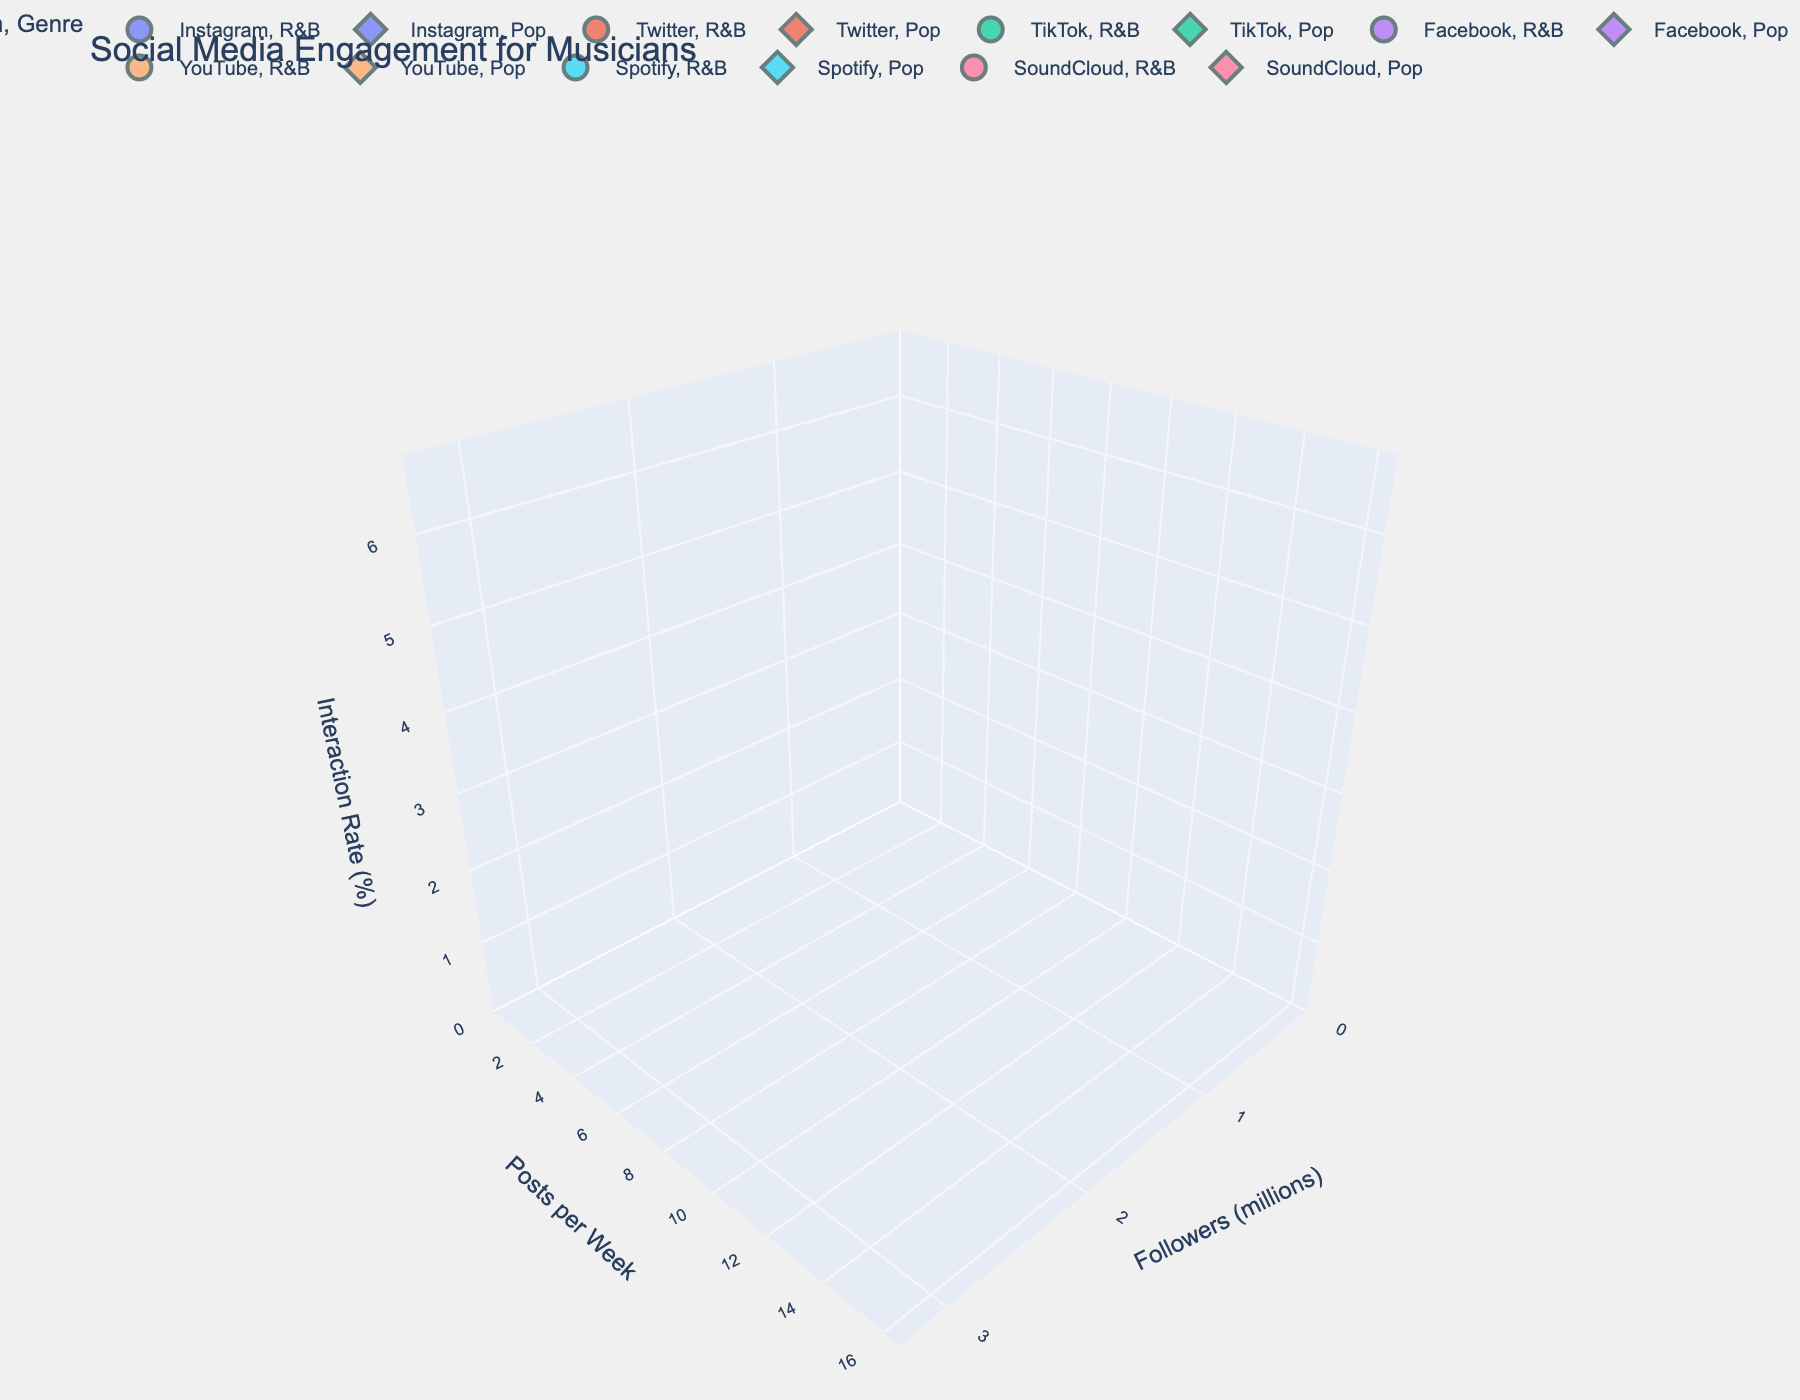What's the title of the plot? The title of the plot is displayed at the top of the figure.
Answer: Social Media Engagement for Musicians Which platform has the highest number of followers? By looking at the x-axis, you can spot the bubbles positioned farthest to the right. The TikTok bubble for Pop genre is the farthest to the right.
Answer: TikTok for Pop What is the post frequency on Spotify for the R&B genre? By identifying the bubble for Spotify in the R&B category and observing its position on the y-axis.
Answer: 1 post per week Which genre generally has higher interaction rates on Instagram? By comparing the z-axis values (interaction rates) for Instagram bubbles in both Pop and R&B genres.
Answer: Pop How do the interaction rates on Facebook compare between the R&B and Pop genres? Comparing the z-axis (interaction rates) for the Facebook bubbles of both genres. Pop has a higher interaction rate on Facebook.
Answer: Pop has a higher rate What is the general trend in interaction rates with increasing followers? Observing the position of the bubbles along the z-axis as you move farther along the x-axis. Generally, interaction rates tend to increase with more followers, especially in Pop.
Answer: Interaction rates increase Between YouTube and Spotify, which platform has higher interaction rates for the R&B genre? Comparing the z-axis values of the YouTube and Spotify bubbles for the R&B genre. YouTube shows a higher interaction rate.
Answer: YouTube Do musicians on TikTok have higher or lower interaction rates compared to the average interaction rate across all platforms? Calculate the average interaction rate by summing all interaction rates and dividing by their count, then compare this to TikTok interaction rates. TikTok has higher interaction rates.
Answer: Higher 